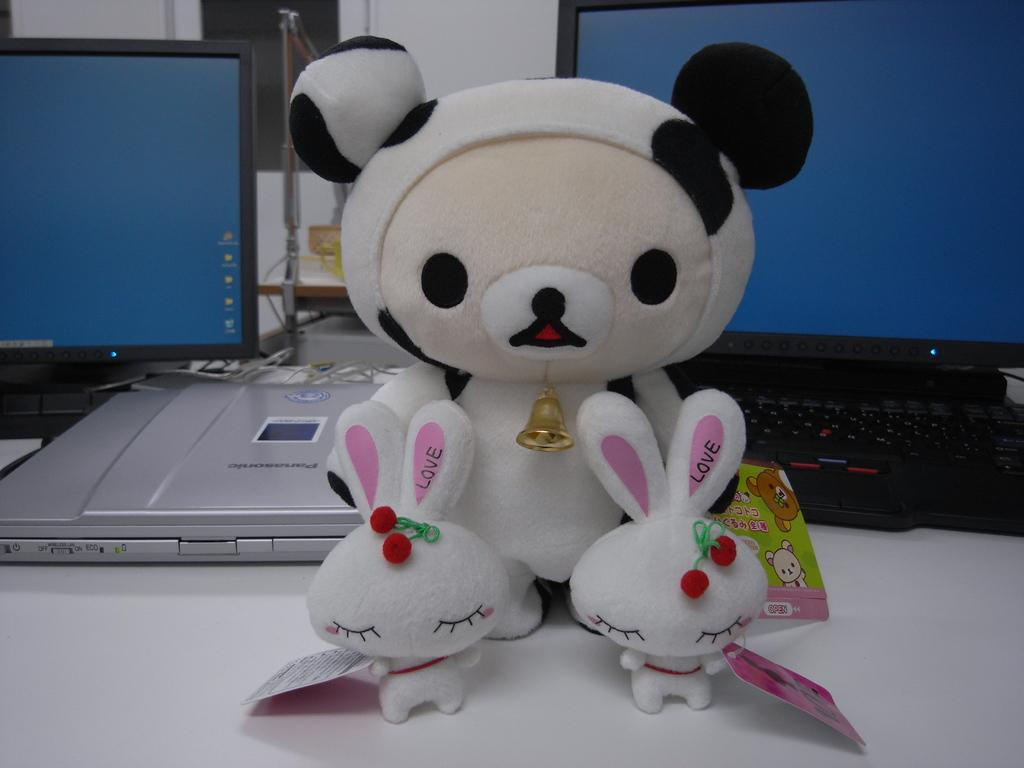What electronic device is visible in the image? There is a computer and a laptop in the image. What other device can be seen in the image? There is another device in the image. What type of object is present on the table in the image? There is a toy on the table in the image. Can you describe the setting where the devices are located? There might be a window in the image, which suggests a room or an indoor setting. What type of hill can be seen in the background of the image? There is no hill visible in the image; it primarily features electronic devices and a toy. 